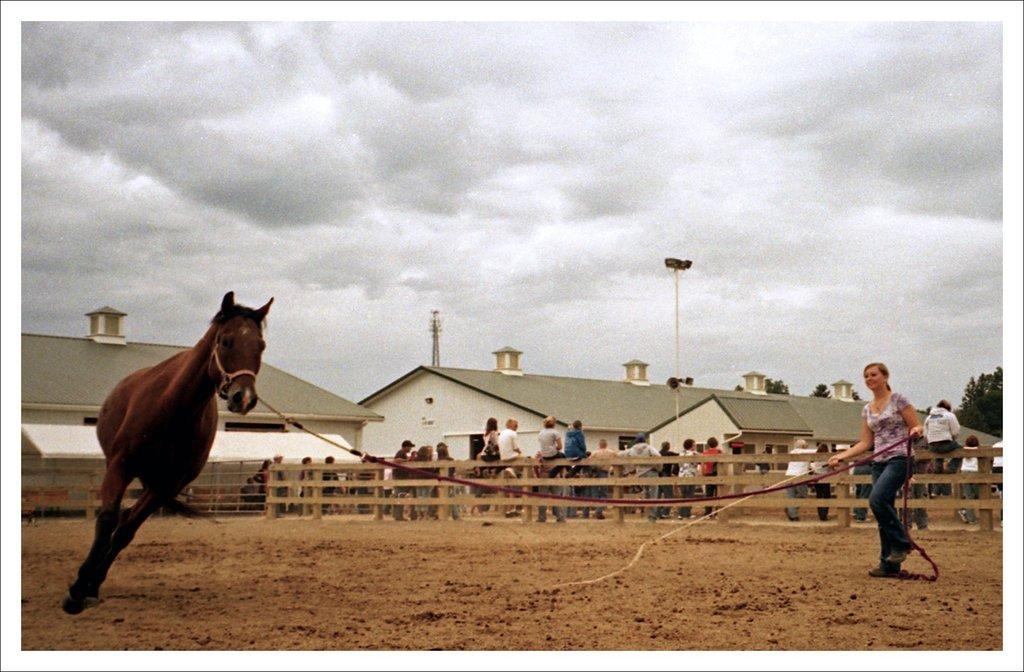Can you describe this image briefly? In this picture I can see there is a woman standing and she is holding a rope and it is tied to the horse, there is soil on the floor. In the backdrop there is a wooden fence, there are a few people sitting on the fence and there are a few more people standing behind the fence and there are two buildings in the backdrop, there are electric poles, there are few trees on right side and the sky is clear. 